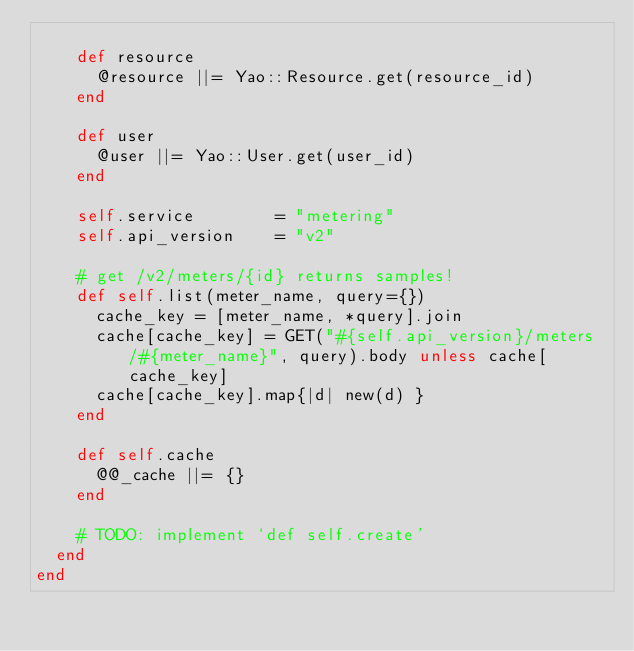Convert code to text. <code><loc_0><loc_0><loc_500><loc_500><_Ruby_>
    def resource
      @resource ||= Yao::Resource.get(resource_id)
    end

    def user
      @user ||= Yao::User.get(user_id)
    end

    self.service        = "metering"
    self.api_version    = "v2"

    # get /v2/meters/{id} returns samples!
    def self.list(meter_name, query={})
      cache_key = [meter_name, *query].join
      cache[cache_key] = GET("#{self.api_version}/meters/#{meter_name}", query).body unless cache[cache_key]
      cache[cache_key].map{|d| new(d) }
    end

    def self.cache
      @@_cache ||= {}
    end

    # TODO: implement `def self.create'
  end
end
</code> 